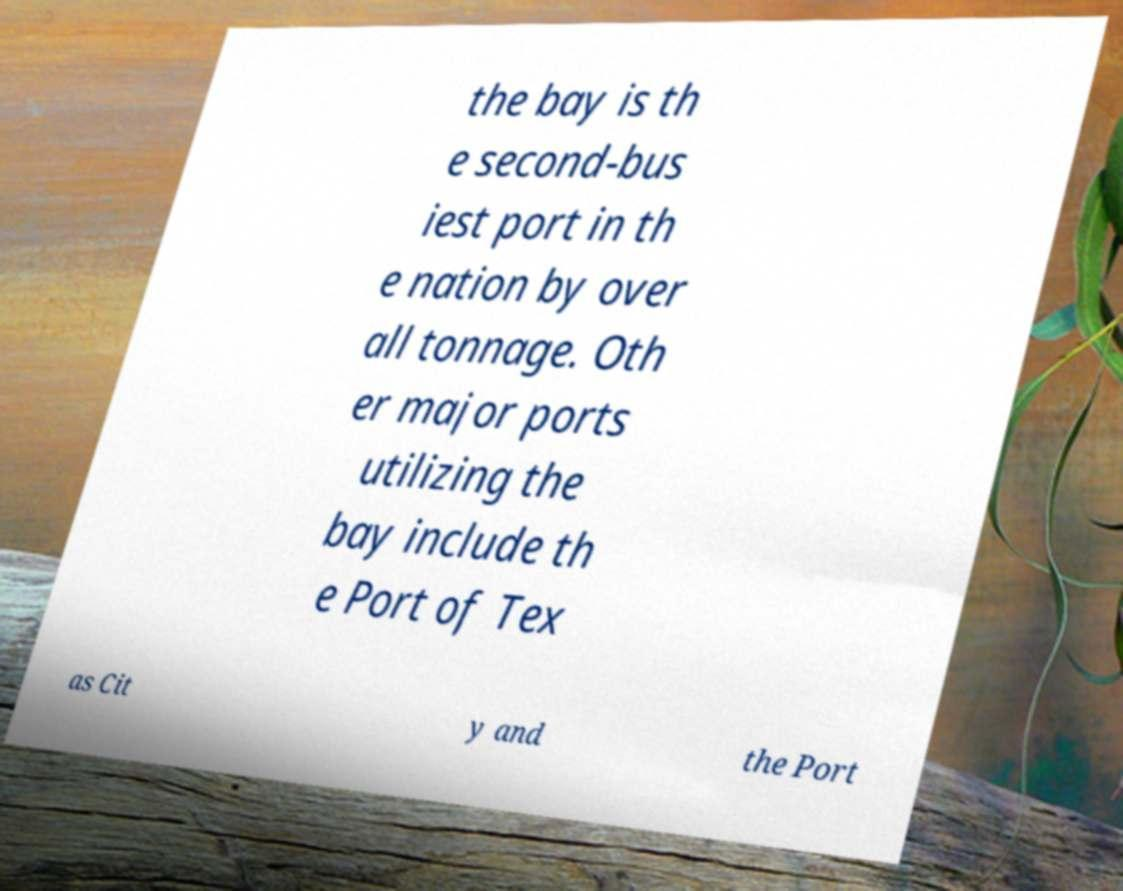Can you read and provide the text displayed in the image?This photo seems to have some interesting text. Can you extract and type it out for me? the bay is th e second-bus iest port in th e nation by over all tonnage. Oth er major ports utilizing the bay include th e Port of Tex as Cit y and the Port 